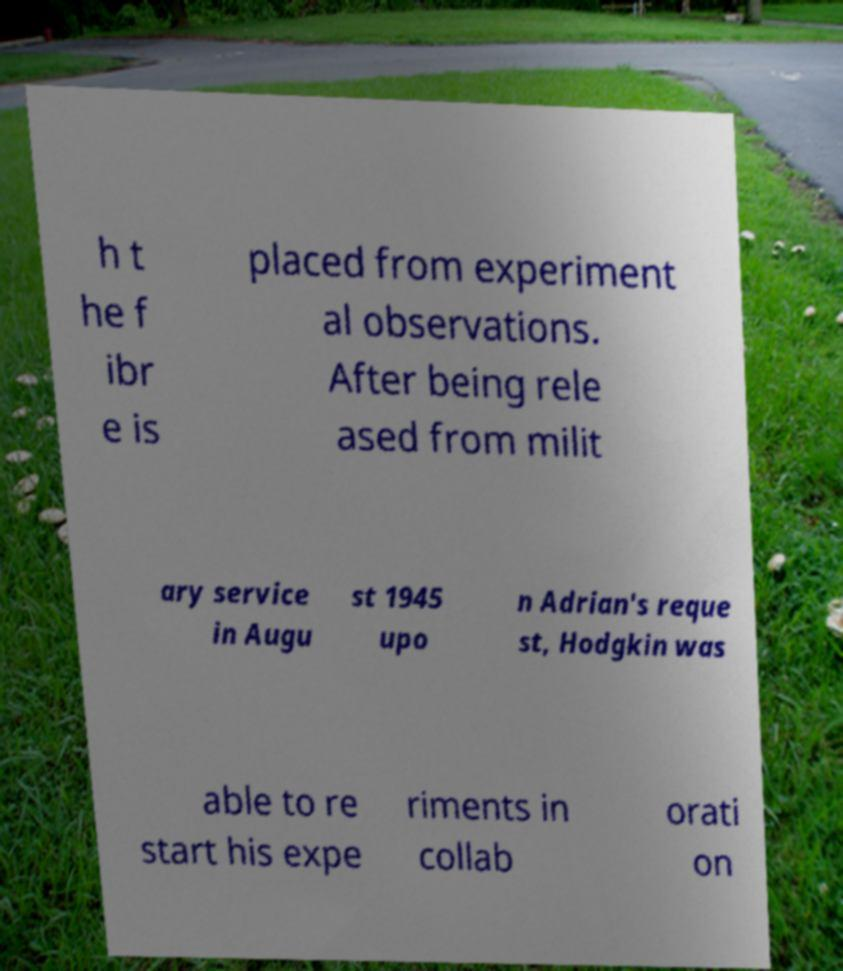Can you read and provide the text displayed in the image?This photo seems to have some interesting text. Can you extract and type it out for me? h t he f ibr e is placed from experiment al observations. After being rele ased from milit ary service in Augu st 1945 upo n Adrian's reque st, Hodgkin was able to re start his expe riments in collab orati on 